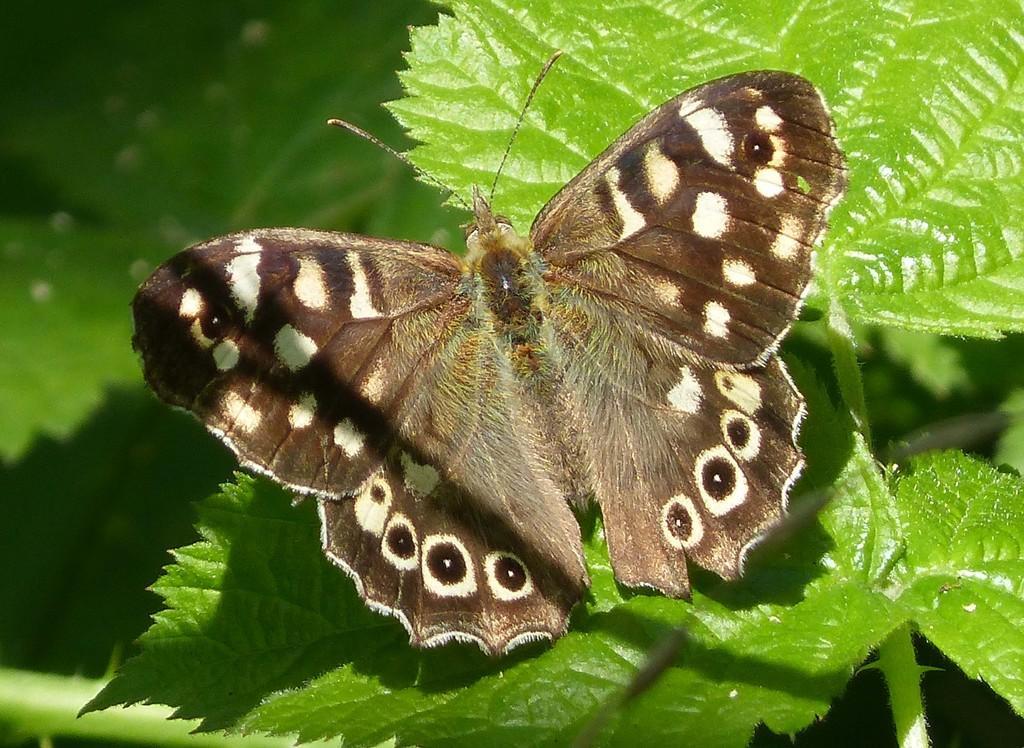In one or two sentences, can you explain what this image depicts? In this picture there is a butterfly on a greenery leaf. 